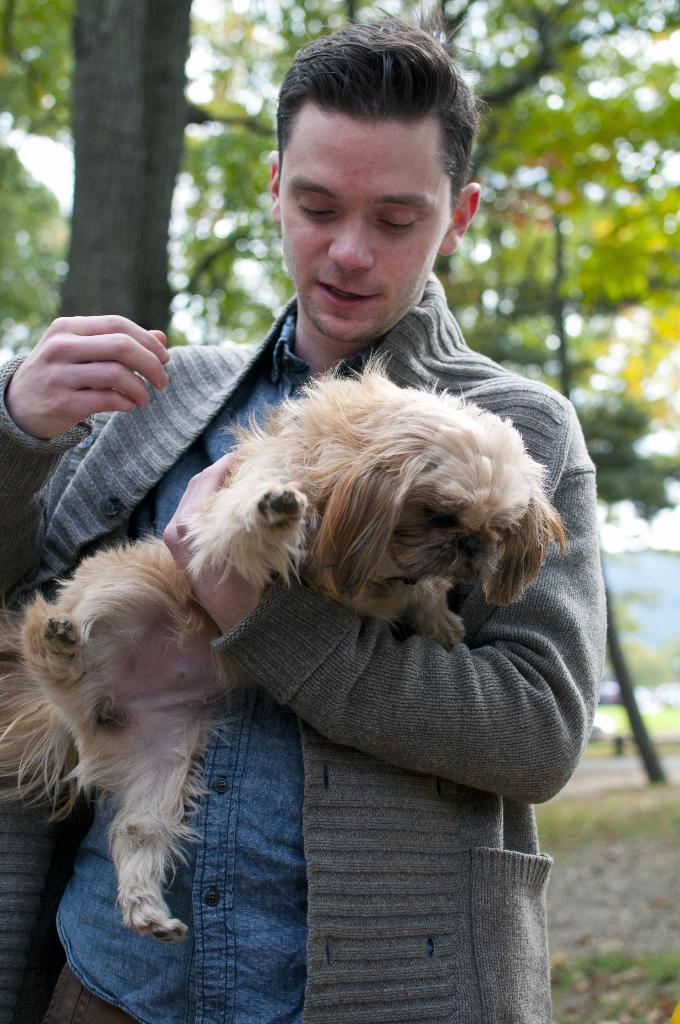What is the man in the image doing? The man is standing in the image and holding a dog. Can you describe the dog in the image? The dog is yellow in color. What can be seen in the background of the image? There is a green color tree in the background of the image. How many sisters does the man have in the image? There is no information about the man's sisters in the image. What type of account does the dog have with the bank in the image? There is no mention of a bank or an account in the image. 